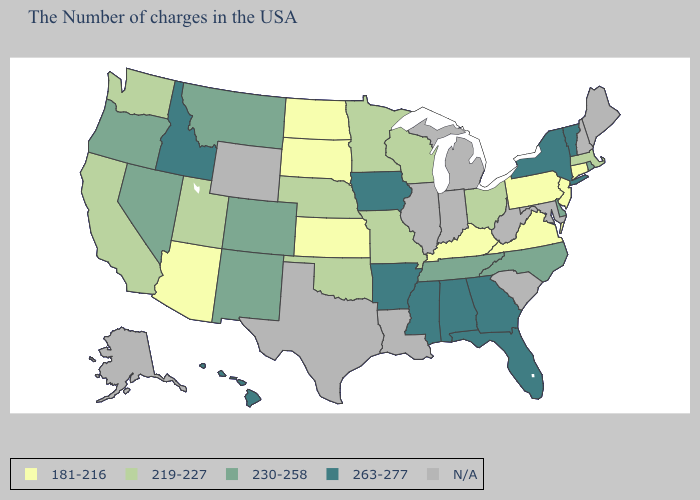What is the value of Oklahoma?
Write a very short answer. 219-227. Name the states that have a value in the range 263-277?
Write a very short answer. Vermont, New York, Florida, Georgia, Alabama, Mississippi, Arkansas, Iowa, Idaho, Hawaii. Name the states that have a value in the range 181-216?
Be succinct. Connecticut, New Jersey, Pennsylvania, Virginia, Kentucky, Kansas, South Dakota, North Dakota, Arizona. What is the value of New Jersey?
Keep it brief. 181-216. Does Vermont have the highest value in the USA?
Give a very brief answer. Yes. Which states have the lowest value in the USA?
Keep it brief. Connecticut, New Jersey, Pennsylvania, Virginia, Kentucky, Kansas, South Dakota, North Dakota, Arizona. Does Pennsylvania have the lowest value in the Northeast?
Answer briefly. Yes. Among the states that border Rhode Island , which have the highest value?
Short answer required. Massachusetts. Name the states that have a value in the range 230-258?
Keep it brief. Rhode Island, Delaware, North Carolina, Tennessee, Colorado, New Mexico, Montana, Nevada, Oregon. Among the states that border North Dakota , does South Dakota have the lowest value?
Answer briefly. Yes. Does Massachusetts have the lowest value in the Northeast?
Keep it brief. No. Name the states that have a value in the range N/A?
Give a very brief answer. Maine, New Hampshire, Maryland, South Carolina, West Virginia, Michigan, Indiana, Illinois, Louisiana, Texas, Wyoming, Alaska. How many symbols are there in the legend?
Concise answer only. 5. What is the value of Missouri?
Short answer required. 219-227. 